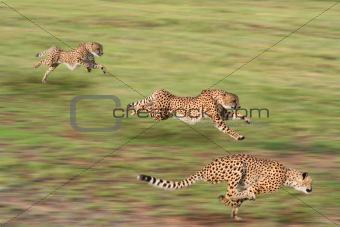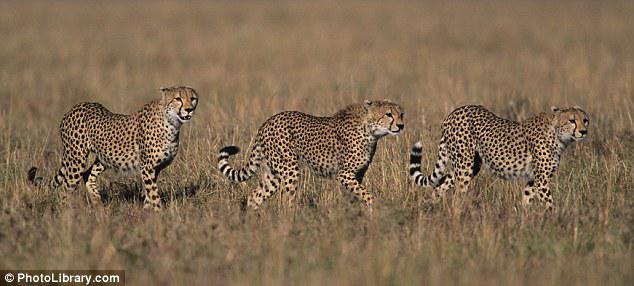The first image is the image on the left, the second image is the image on the right. Considering the images on both sides, is "One of the large cats is biting an antelope." valid? Answer yes or no. No. The first image is the image on the left, the second image is the image on the right. For the images shown, is this caption "The image on the right contains no more than three cheetahs." true? Answer yes or no. Yes. The first image is the image on the left, the second image is the image on the right. For the images shown, is this caption "There are more than 5 animals in the picture." true? Answer yes or no. Yes. 